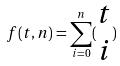<formula> <loc_0><loc_0><loc_500><loc_500>f ( t , n ) = \sum _ { i = 0 } ^ { n } ( \begin{matrix} t \\ i \end{matrix} )</formula> 